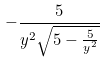<formula> <loc_0><loc_0><loc_500><loc_500>- \frac { 5 } { y ^ { 2 } \sqrt { 5 - \frac { 5 } { y ^ { 2 } } } }</formula> 